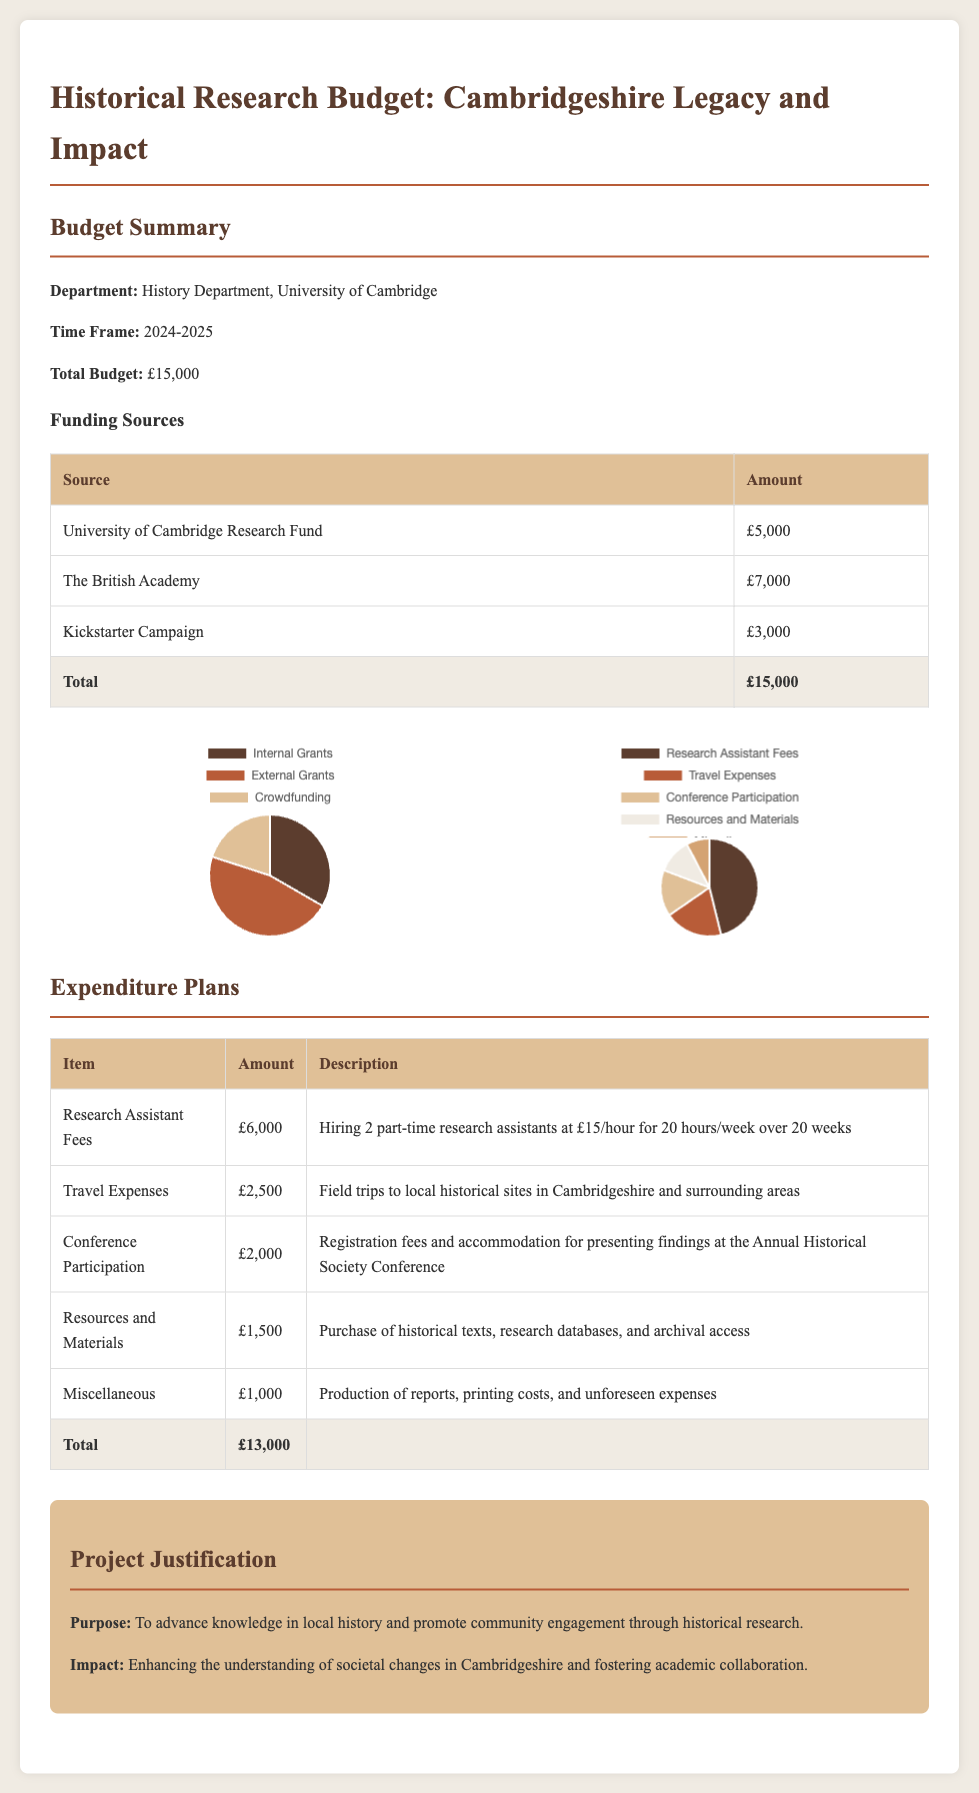What is the total budget? The total budget is stated in the document as £15,000.
Answer: £15,000 Who is the department responsible for this budget? The document specifies that the responsible department is the History Department at the University of Cambridge.
Answer: History Department, University of Cambridge How much funding is received from The British Academy? The document lists the funding from The British Academy as £7,000.
Answer: £7,000 What is the amount allocated for research assistant fees? The expenditure plan specifies that £6,000 is allocated for research assistant fees.
Answer: £6,000 What is the purpose of the project? The purpose, as described in the document, is to advance knowledge in local history and promote community engagement through historical research.
Answer: Advance knowledge in local history How many research assistants are being hired? According to the expenditure plans, 2 part-time research assistants are being hired.
Answer: 2 What is the total amount for travel expenses? The document indicates that the total amount allocated for travel expenses is £2,500.
Answer: £2,500 Which source contributes the least amount of funding? The Kickstarter Campaign contributes the least amount of funding at £3,000, compared to others.
Answer: Kickstarter Campaign What percentage of the budget is accounted for by Conference Participation? The Conference Participation amount is £2,000, which is approximately 13.33% of the total budget.
Answer: 13.33% 